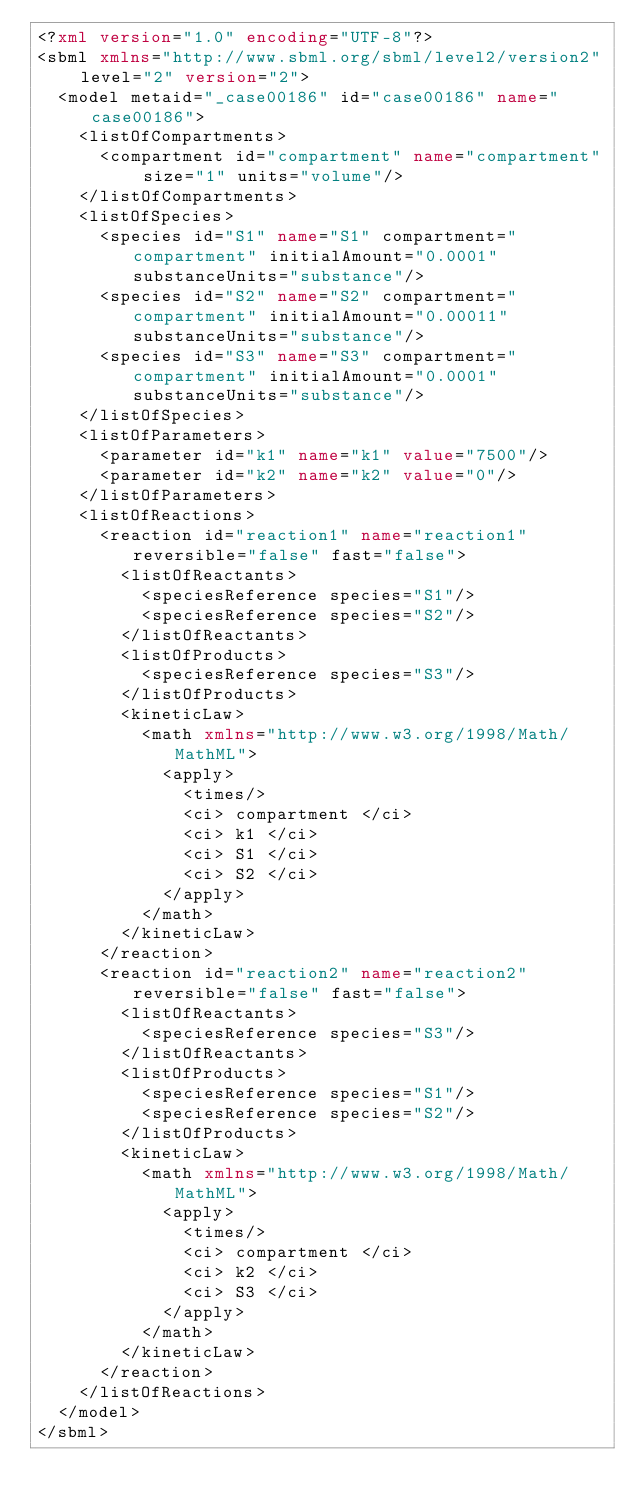Convert code to text. <code><loc_0><loc_0><loc_500><loc_500><_XML_><?xml version="1.0" encoding="UTF-8"?>
<sbml xmlns="http://www.sbml.org/sbml/level2/version2" level="2" version="2">
  <model metaid="_case00186" id="case00186" name="case00186">
    <listOfCompartments>
      <compartment id="compartment" name="compartment" size="1" units="volume"/>
    </listOfCompartments>
    <listOfSpecies>
      <species id="S1" name="S1" compartment="compartment" initialAmount="0.0001" substanceUnits="substance"/>
      <species id="S2" name="S2" compartment="compartment" initialAmount="0.00011" substanceUnits="substance"/>
      <species id="S3" name="S3" compartment="compartment" initialAmount="0.0001" substanceUnits="substance"/>
    </listOfSpecies>
    <listOfParameters>
      <parameter id="k1" name="k1" value="7500"/>
      <parameter id="k2" name="k2" value="0"/>
    </listOfParameters>
    <listOfReactions>
      <reaction id="reaction1" name="reaction1" reversible="false" fast="false">
        <listOfReactants>
          <speciesReference species="S1"/>
          <speciesReference species="S2"/>
        </listOfReactants>
        <listOfProducts>
          <speciesReference species="S3"/>
        </listOfProducts>
        <kineticLaw>
          <math xmlns="http://www.w3.org/1998/Math/MathML">
            <apply>
              <times/>
              <ci> compartment </ci>
              <ci> k1 </ci>
              <ci> S1 </ci>
              <ci> S2 </ci>
            </apply>
          </math>
        </kineticLaw>
      </reaction>
      <reaction id="reaction2" name="reaction2" reversible="false" fast="false">
        <listOfReactants>
          <speciesReference species="S3"/>
        </listOfReactants>
        <listOfProducts>
          <speciesReference species="S1"/>
          <speciesReference species="S2"/>
        </listOfProducts>
        <kineticLaw>
          <math xmlns="http://www.w3.org/1998/Math/MathML">
            <apply>
              <times/>
              <ci> compartment </ci>
              <ci> k2 </ci>
              <ci> S3 </ci>
            </apply>
          </math>
        </kineticLaw>
      </reaction>
    </listOfReactions>
  </model>
</sbml>
</code> 